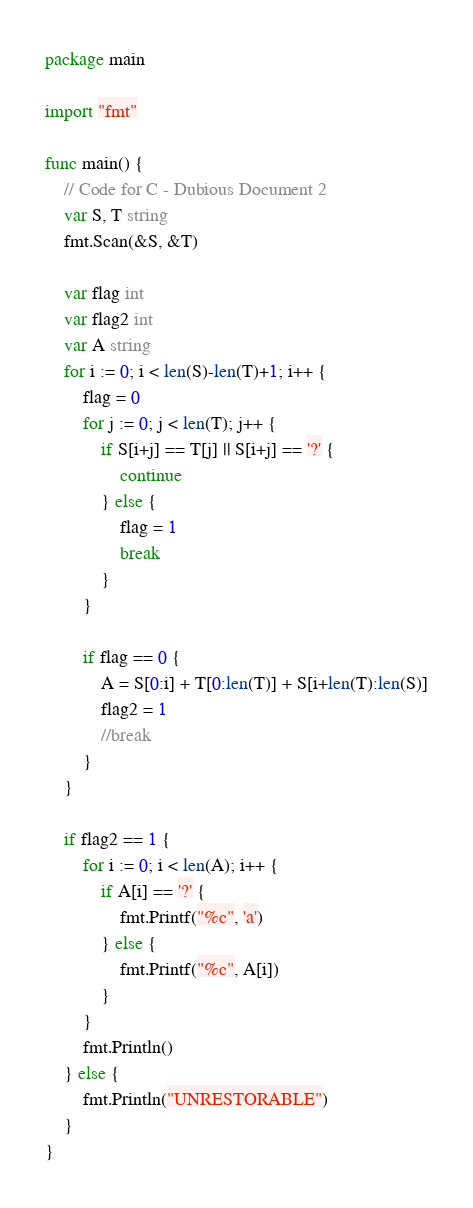<code> <loc_0><loc_0><loc_500><loc_500><_Go_>package main

import "fmt"

func main() {
	// Code for C - Dubious Document 2
	var S, T string
	fmt.Scan(&S, &T)

	var flag int
	var flag2 int
	var A string
	for i := 0; i < len(S)-len(T)+1; i++ {
		flag = 0
		for j := 0; j < len(T); j++ {
			if S[i+j] == T[j] || S[i+j] == '?' {
				continue
			} else {
				flag = 1
				break
			}
		}

		if flag == 0 {
			A = S[0:i] + T[0:len(T)] + S[i+len(T):len(S)]
			flag2 = 1
			//break
		}
	}

	if flag2 == 1 {
		for i := 0; i < len(A); i++ {
			if A[i] == '?' {
				fmt.Printf("%c", 'a')
			} else {
				fmt.Printf("%c", A[i])
			}
		}
		fmt.Println()
	} else {
		fmt.Println("UNRESTORABLE")
	}
}
</code> 